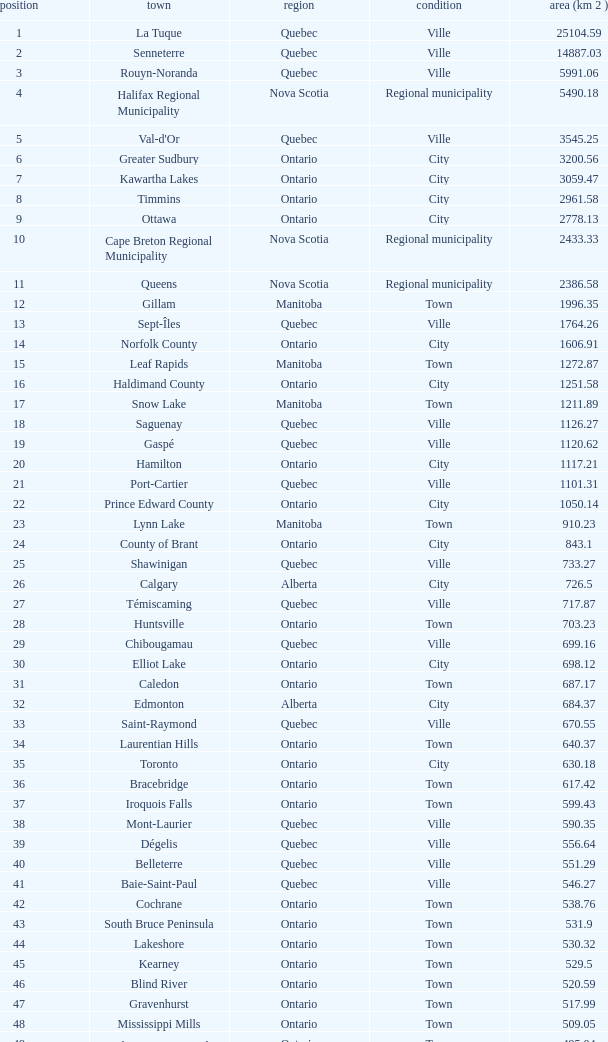What is the total Rank that has a Municipality of Winnipeg, an Area (KM 2) that's larger than 464.01? None. Can you give me this table as a dict? {'header': ['position', 'town', 'region', 'condition', 'area (km 2 )'], 'rows': [['1', 'La Tuque', 'Quebec', 'Ville', '25104.59'], ['2', 'Senneterre', 'Quebec', 'Ville', '14887.03'], ['3', 'Rouyn-Noranda', 'Quebec', 'Ville', '5991.06'], ['4', 'Halifax Regional Municipality', 'Nova Scotia', 'Regional municipality', '5490.18'], ['5', "Val-d'Or", 'Quebec', 'Ville', '3545.25'], ['6', 'Greater Sudbury', 'Ontario', 'City', '3200.56'], ['7', 'Kawartha Lakes', 'Ontario', 'City', '3059.47'], ['8', 'Timmins', 'Ontario', 'City', '2961.58'], ['9', 'Ottawa', 'Ontario', 'City', '2778.13'], ['10', 'Cape Breton Regional Municipality', 'Nova Scotia', 'Regional municipality', '2433.33'], ['11', 'Queens', 'Nova Scotia', 'Regional municipality', '2386.58'], ['12', 'Gillam', 'Manitoba', 'Town', '1996.35'], ['13', 'Sept-Îles', 'Quebec', 'Ville', '1764.26'], ['14', 'Norfolk County', 'Ontario', 'City', '1606.91'], ['15', 'Leaf Rapids', 'Manitoba', 'Town', '1272.87'], ['16', 'Haldimand County', 'Ontario', 'City', '1251.58'], ['17', 'Snow Lake', 'Manitoba', 'Town', '1211.89'], ['18', 'Saguenay', 'Quebec', 'Ville', '1126.27'], ['19', 'Gaspé', 'Quebec', 'Ville', '1120.62'], ['20', 'Hamilton', 'Ontario', 'City', '1117.21'], ['21', 'Port-Cartier', 'Quebec', 'Ville', '1101.31'], ['22', 'Prince Edward County', 'Ontario', 'City', '1050.14'], ['23', 'Lynn Lake', 'Manitoba', 'Town', '910.23'], ['24', 'County of Brant', 'Ontario', 'City', '843.1'], ['25', 'Shawinigan', 'Quebec', 'Ville', '733.27'], ['26', 'Calgary', 'Alberta', 'City', '726.5'], ['27', 'Témiscaming', 'Quebec', 'Ville', '717.87'], ['28', 'Huntsville', 'Ontario', 'Town', '703.23'], ['29', 'Chibougamau', 'Quebec', 'Ville', '699.16'], ['30', 'Elliot Lake', 'Ontario', 'City', '698.12'], ['31', 'Caledon', 'Ontario', 'Town', '687.17'], ['32', 'Edmonton', 'Alberta', 'City', '684.37'], ['33', 'Saint-Raymond', 'Quebec', 'Ville', '670.55'], ['34', 'Laurentian Hills', 'Ontario', 'Town', '640.37'], ['35', 'Toronto', 'Ontario', 'City', '630.18'], ['36', 'Bracebridge', 'Ontario', 'Town', '617.42'], ['37', 'Iroquois Falls', 'Ontario', 'Town', '599.43'], ['38', 'Mont-Laurier', 'Quebec', 'Ville', '590.35'], ['39', 'Dégelis', 'Quebec', 'Ville', '556.64'], ['40', 'Belleterre', 'Quebec', 'Ville', '551.29'], ['41', 'Baie-Saint-Paul', 'Quebec', 'Ville', '546.27'], ['42', 'Cochrane', 'Ontario', 'Town', '538.76'], ['43', 'South Bruce Peninsula', 'Ontario', 'Town', '531.9'], ['44', 'Lakeshore', 'Ontario', 'Town', '530.32'], ['45', 'Kearney', 'Ontario', 'Town', '529.5'], ['46', 'Blind River', 'Ontario', 'Town', '520.59'], ['47', 'Gravenhurst', 'Ontario', 'Town', '517.99'], ['48', 'Mississippi Mills', 'Ontario', 'Town', '509.05'], ['49', 'Northeastern Manitoulin and the Islands', 'Ontario', 'Town', '495.04'], ['50', 'Quinte West', 'Ontario', 'City', '493.85'], ['51', 'Mirabel', 'Quebec', 'Ville', '485.51'], ['52', 'Fermont', 'Quebec', 'Ville', '470.67'], ['53', 'Winnipeg', 'Manitoba', 'City', '464.01'], ['54', 'Greater Napanee', 'Ontario', 'Town', '459.71'], ['55', 'La Malbaie', 'Quebec', 'Ville', '459.34'], ['56', 'Rivière-Rouge', 'Quebec', 'Ville', '454.99'], ['57', 'Québec City', 'Quebec', 'Ville', '454.26'], ['58', 'Kingston', 'Ontario', 'City', '450.39'], ['59', 'Lévis', 'Quebec', 'Ville', '449.32'], ['60', "St. John's", 'Newfoundland and Labrador', 'City', '446.04'], ['61', 'Bécancour', 'Quebec', 'Ville', '441'], ['62', 'Percé', 'Quebec', 'Ville', '432.39'], ['63', 'Amos', 'Quebec', 'Ville', '430.06'], ['64', 'London', 'Ontario', 'City', '420.57'], ['65', 'Chandler', 'Quebec', 'Ville', '419.5'], ['66', 'Whitehorse', 'Yukon', 'City', '416.43'], ['67', 'Gracefield', 'Quebec', 'Ville', '386.21'], ['68', 'Baie Verte', 'Newfoundland and Labrador', 'Town', '371.07'], ['69', 'Milton', 'Ontario', 'Town', '366.61'], ['70', 'Montreal', 'Quebec', 'Ville', '365.13'], ['71', 'Saint-Félicien', 'Quebec', 'Ville', '363.57'], ['72', 'Abbotsford', 'British Columbia', 'City', '359.36'], ['73', 'Sherbrooke', 'Quebec', 'Ville', '353.46'], ['74', 'Gatineau', 'Quebec', 'Ville', '342.32'], ['75', 'Pohénégamook', 'Quebec', 'Ville', '340.33'], ['76', 'Baie-Comeau', 'Quebec', 'Ville', '338.88'], ['77', 'Thunder Bay', 'Ontario', 'City', '328.48'], ['78', 'Plympton–Wyoming', 'Ontario', 'Town', '318.76'], ['79', 'Surrey', 'British Columbia', 'City', '317.19'], ['80', 'Prince George', 'British Columbia', 'City', '316'], ['81', 'Saint John', 'New Brunswick', 'City', '315.49'], ['82', 'North Bay', 'Ontario', 'City', '314.91'], ['83', 'Happy Valley-Goose Bay', 'Newfoundland and Labrador', 'Town', '305.85'], ['84', 'Minto', 'Ontario', 'Town', '300.37'], ['85', 'Kamloops', 'British Columbia', 'City', '297.3'], ['86', 'Erin', 'Ontario', 'Town', '296.98'], ['87', 'Clarence-Rockland', 'Ontario', 'City', '296.53'], ['88', 'Cookshire-Eaton', 'Quebec', 'Ville', '295.93'], ['89', 'Dolbeau-Mistassini', 'Quebec', 'Ville', '295.67'], ['90', 'Trois-Rivières', 'Quebec', 'Ville', '288.92'], ['91', 'Mississauga', 'Ontario', 'City', '288.53'], ['92', 'Georgina', 'Ontario', 'Town', '287.72'], ['93', 'The Blue Mountains', 'Ontario', 'Town', '286.78'], ['94', 'Innisfil', 'Ontario', 'Town', '284.18'], ['95', 'Essex', 'Ontario', 'Town', '277.95'], ['96', 'Mono', 'Ontario', 'Town', '277.67'], ['97', 'Halton Hills', 'Ontario', 'Town', '276.26'], ['98', 'New Tecumseth', 'Ontario', 'Town', '274.18'], ['99', 'Vaughan', 'Ontario', 'City', '273.58'], ['100', 'Brampton', 'Ontario', 'City', '266.71']]} 